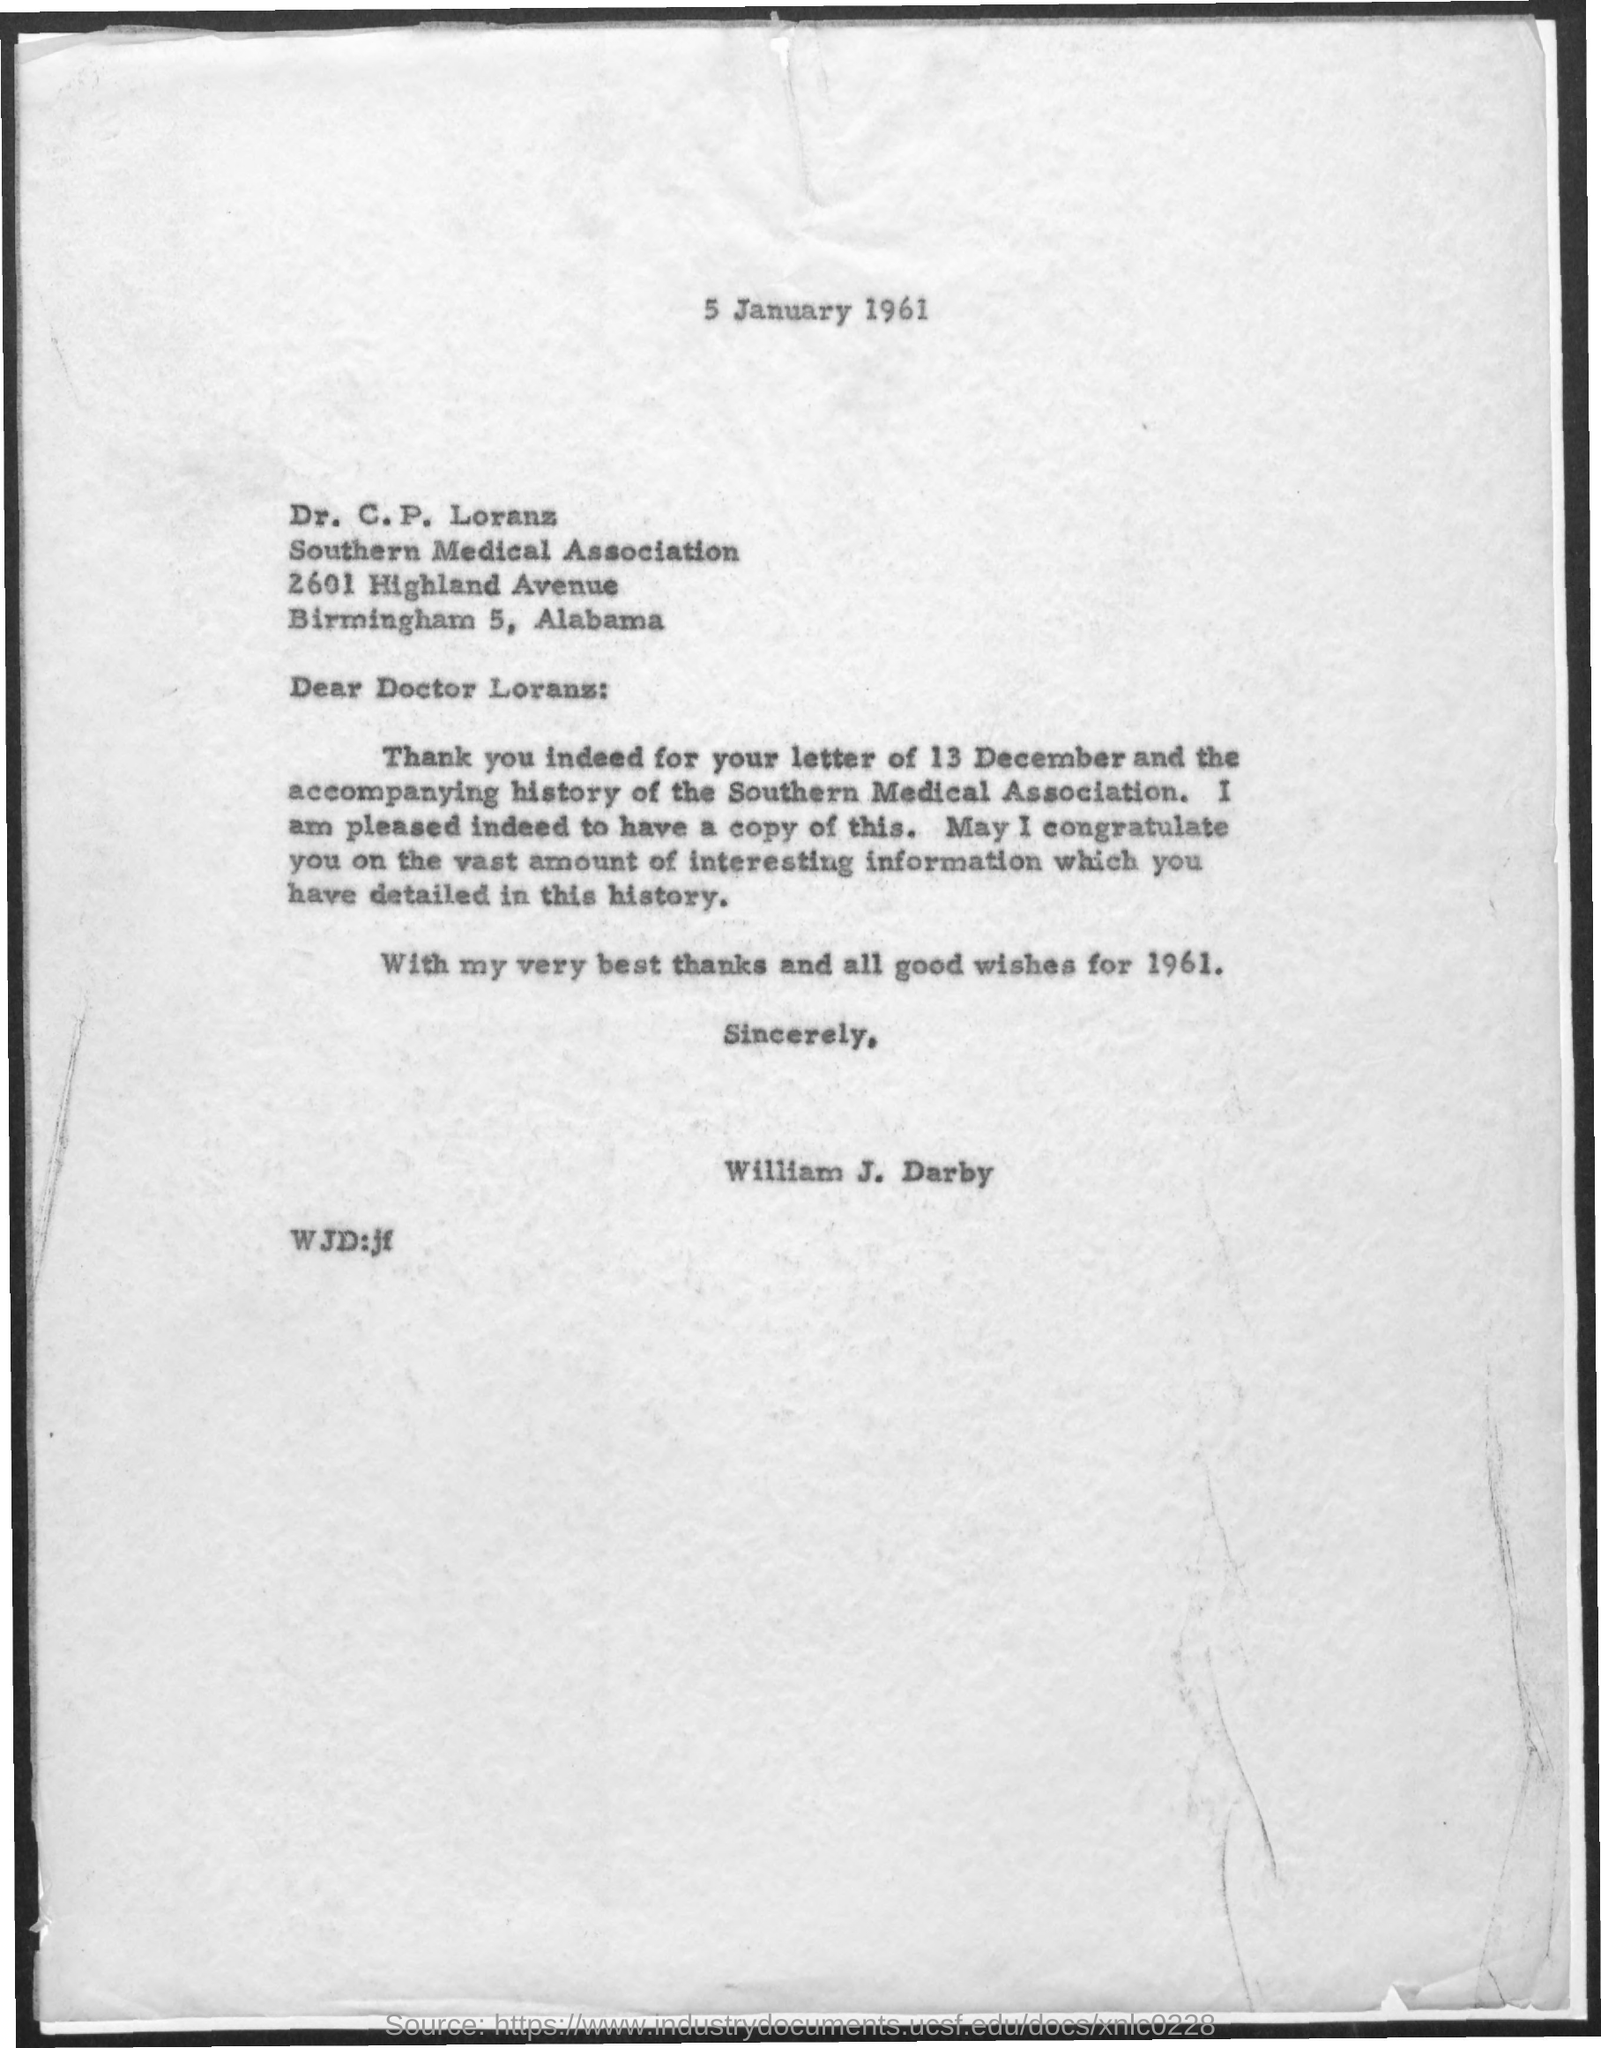What is the date at top of the page?
Offer a terse response. 5 January 1961. Who wrote this letter?
Your response must be concise. William J. Darby. 